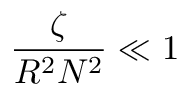Convert formula to latex. <formula><loc_0><loc_0><loc_500><loc_500>{ \frac { \zeta } { R ^ { 2 } N ^ { 2 } } } \ll 1</formula> 